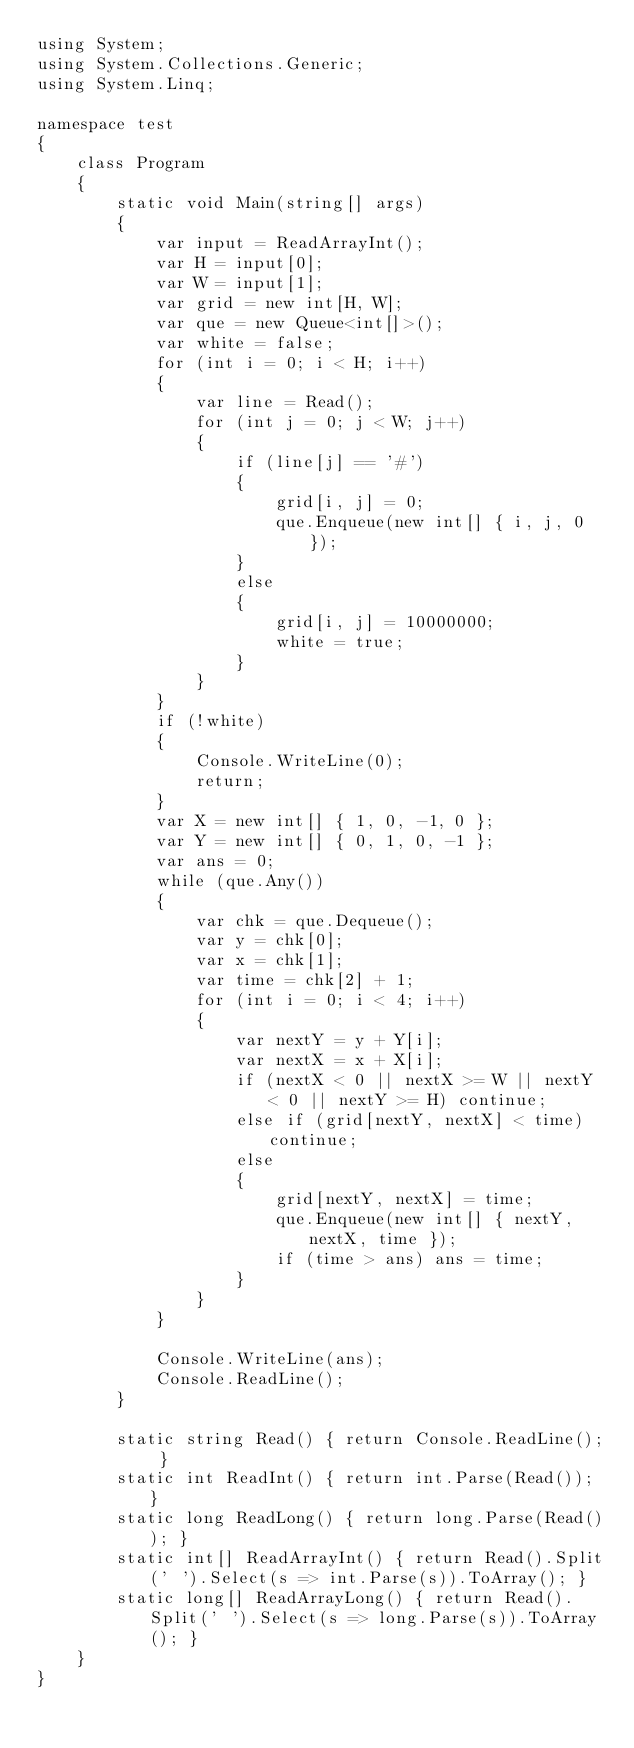<code> <loc_0><loc_0><loc_500><loc_500><_C#_>using System;
using System.Collections.Generic;
using System.Linq;

namespace test
{
    class Program
    {
        static void Main(string[] args)
        {
            var input = ReadArrayInt();
            var H = input[0];
            var W = input[1];
            var grid = new int[H, W];
            var que = new Queue<int[]>();
            var white = false;
            for (int i = 0; i < H; i++)
            {
                var line = Read();
                for (int j = 0; j < W; j++)
                {
                    if (line[j] == '#')
                    {
                        grid[i, j] = 0;
                        que.Enqueue(new int[] { i, j, 0 });
                    }
                    else
                    {
                        grid[i, j] = 10000000;
                        white = true;
                    }
                }
            }
            if (!white)
            {
                Console.WriteLine(0);
                return;
            }
            var X = new int[] { 1, 0, -1, 0 };
            var Y = new int[] { 0, 1, 0, -1 };
            var ans = 0;
            while (que.Any())
            {
                var chk = que.Dequeue();
                var y = chk[0];
                var x = chk[1];
                var time = chk[2] + 1;
                for (int i = 0; i < 4; i++)
                {
                    var nextY = y + Y[i];
                    var nextX = x + X[i];
                    if (nextX < 0 || nextX >= W || nextY < 0 || nextY >= H) continue;
                    else if (grid[nextY, nextX] < time) continue;
                    else
                    {
                        grid[nextY, nextX] = time;
                        que.Enqueue(new int[] { nextY, nextX, time });
                        if (time > ans) ans = time;
                    }
                }
            }

            Console.WriteLine(ans);
            Console.ReadLine();
        }

        static string Read() { return Console.ReadLine(); }
        static int ReadInt() { return int.Parse(Read()); }
        static long ReadLong() { return long.Parse(Read()); }
        static int[] ReadArrayInt() { return Read().Split(' ').Select(s => int.Parse(s)).ToArray(); }
        static long[] ReadArrayLong() { return Read().Split(' ').Select(s => long.Parse(s)).ToArray(); }
    }
}</code> 